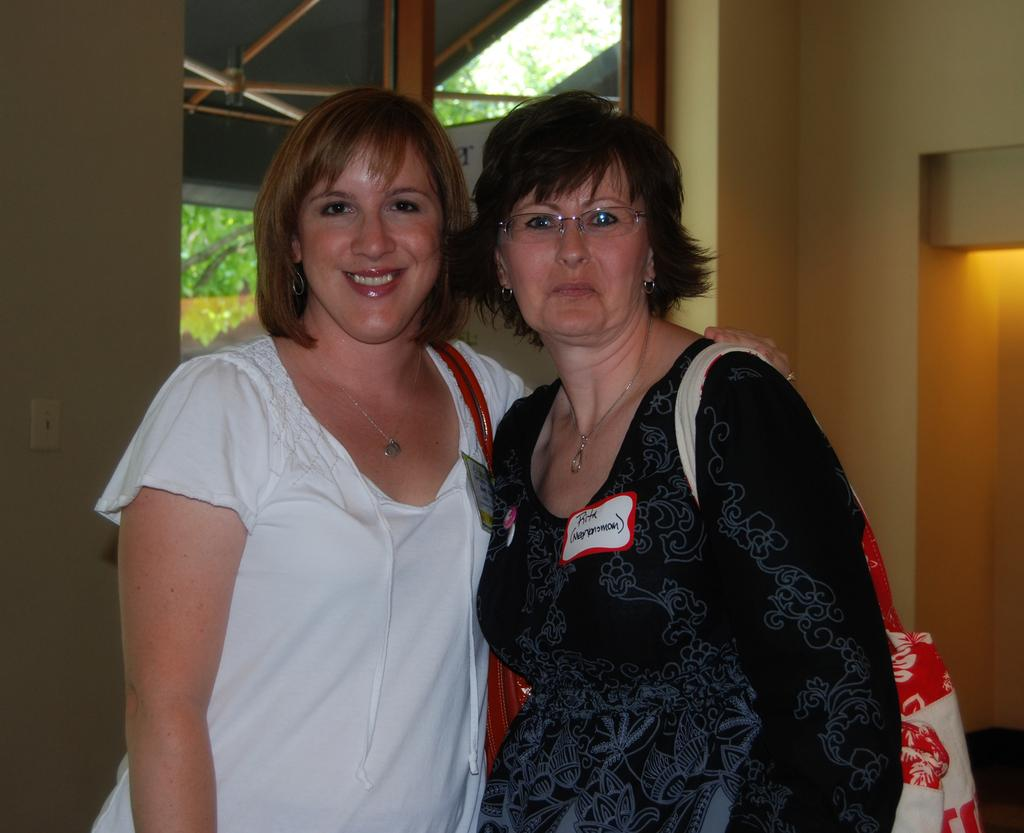How many people are in the image? There are two persons standing in the center of the image. What can be seen in the background of the image? There is a wall in the background of the image. Where is the door located in the image? The door is to the right side of the image. Is there any opening for light or ventilation in the image? Yes, there is a window in the image. What type of pear is being used as a weapon in the fight depicted in the image? There is no fight or pear present in the image; it features two persons standing in the center with a wall, door, and window in the background. 